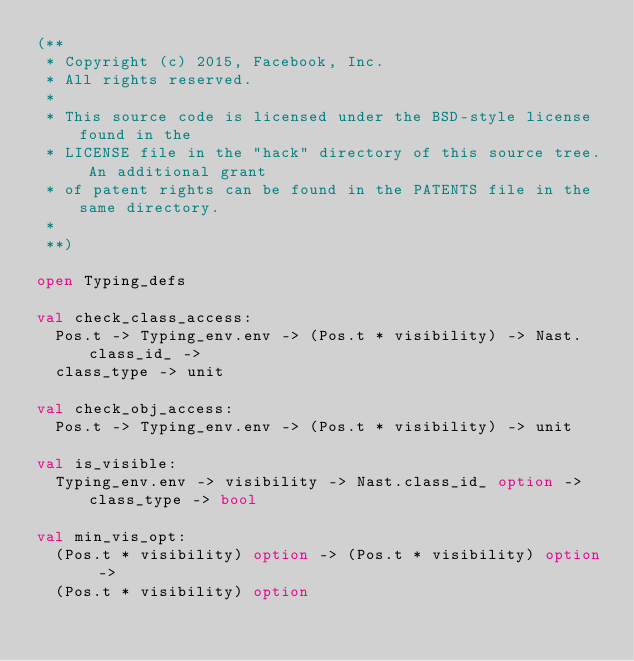<code> <loc_0><loc_0><loc_500><loc_500><_OCaml_>(**
 * Copyright (c) 2015, Facebook, Inc.
 * All rights reserved.
 *
 * This source code is licensed under the BSD-style license found in the
 * LICENSE file in the "hack" directory of this source tree. An additional grant
 * of patent rights can be found in the PATENTS file in the same directory.
 *
 **)

open Typing_defs

val check_class_access:
  Pos.t -> Typing_env.env -> (Pos.t * visibility) -> Nast.class_id_ ->
  class_type -> unit

val check_obj_access:
  Pos.t -> Typing_env.env -> (Pos.t * visibility) -> unit

val is_visible:
  Typing_env.env -> visibility -> Nast.class_id_ option -> class_type -> bool

val min_vis_opt:
  (Pos.t * visibility) option -> (Pos.t * visibility) option ->
  (Pos.t * visibility) option
</code> 